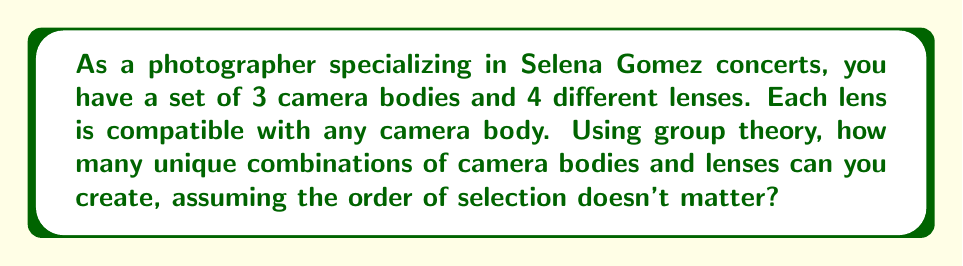Can you solve this math problem? To solve this problem using group theory, we can consider the set of camera bodies and lenses as elements of a group, and the act of combining them as a group operation.

1) First, let's define our sets:
   Let $C = \{c_1, c_2, c_3\}$ be the set of camera bodies
   Let $L = \{l_1, l_2, l_3, l_4\}$ be the set of lenses

2) The combination of a camera body and a lens can be thought of as an element in the Cartesian product $C \times L$.

3) However, since the order doesn't matter (i.e., selecting a camera body first and then a lens is the same as selecting a lens first and then a camera body), we're actually looking at the orbit of this action under the symmetric group $S_2$.

4) In group theory, this is equivalent to finding the number of orbits under the action of $S_2$ on $C \times L$.

5) We can use Burnside's lemma to count the number of orbits:

   $$|X/G| = \frac{1}{|G|} \sum_{g \in G} |X^g|$$

   Where $X$ is our set $C \times L$, $G$ is $S_2$, and $X^g$ is the set of elements fixed by $g$.

6) $|G| = |S_2| = 2$ (identity and transposition)

7) For the identity element, all elements are fixed: $|X^e| = |C \times L| = 3 \times 4 = 12$

8) For the transposition, no elements are fixed: $|X^t| = 0$

9) Applying Burnside's lemma:

   $$|X/G| = \frac{1}{2}(12 + 0) = 6$$

Therefore, there are 6 unique combinations of camera bodies and lenses.
Answer: 6 unique combinations 